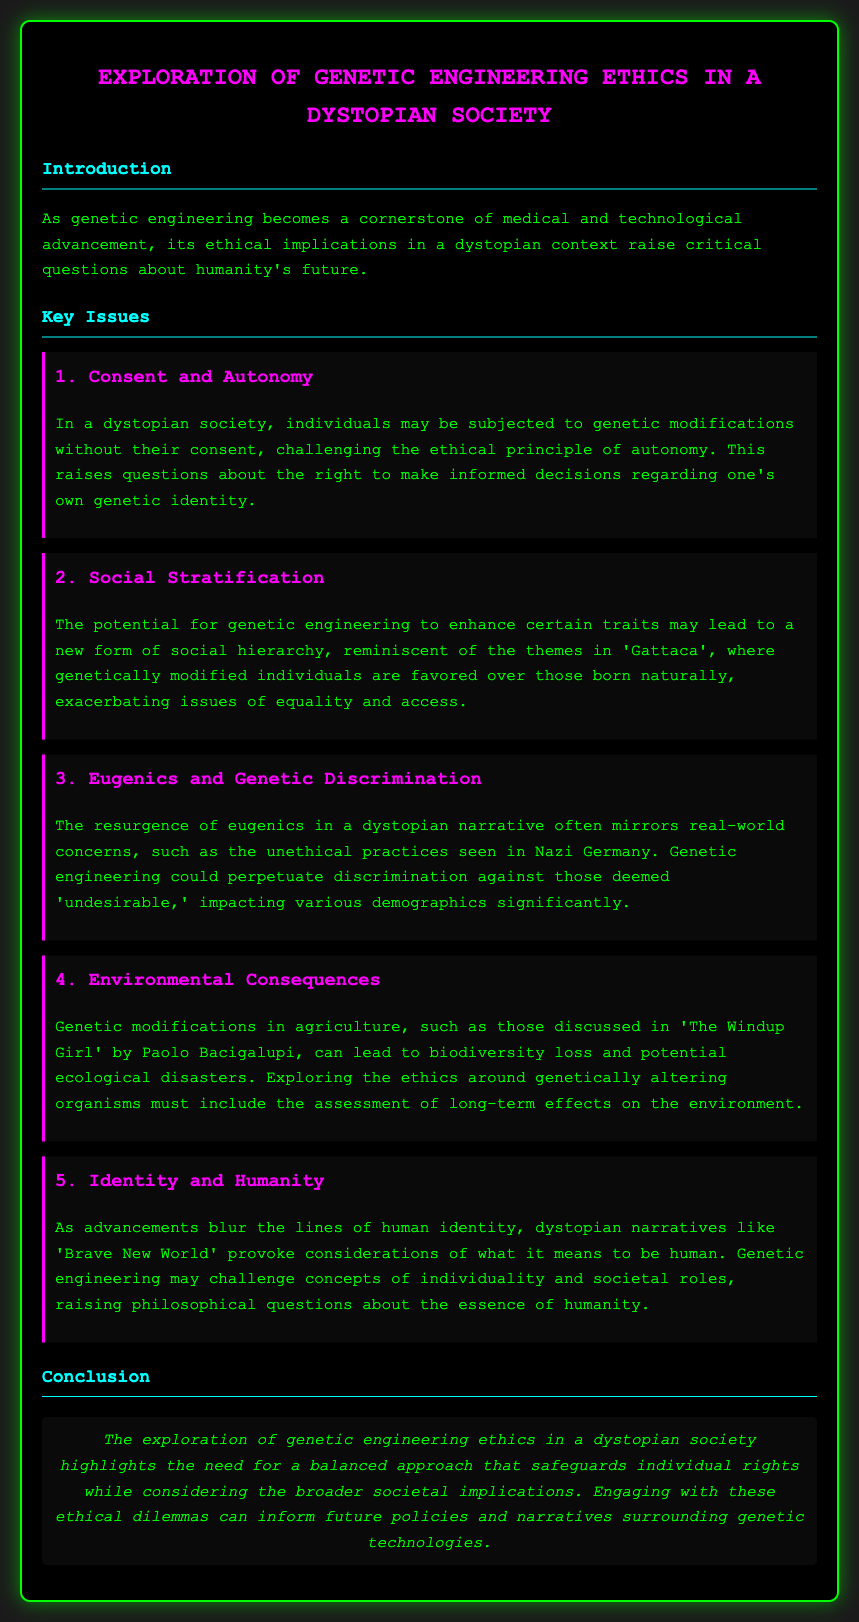What is the main topic of the document? The main topic is the ethical implications of genetic engineering in a dystopian society.
Answer: genetic engineering ethics in a dystopian society What does the first key issue address? The first key issue addresses the challenges related to individual rights in genetic modifications.
Answer: Consent and Autonomy Which dystopian narrative is mentioned in connection with social hierarchy? The narrative mentioned in connection with social hierarchy is 'Gattaca'.
Answer: Gattaca What unethical practices are referenced in the context of eugenics? The reference is made to the unethical practices seen in Nazi Germany.
Answer: Nazi Germany What does the key issue about environmental consequences emphasize? It emphasizes the potential ecological disasters due to genetic modifications in agriculture.
Answer: biodiversity loss and potential ecological disasters How many key issues are outlined in the document? There are five key issues outlined in the document.
Answer: five What philosophical question does genetic engineering raise according to the document? It raises questions about the essence of humanity and individuality.
Answer: essence of humanity What is the need highlighted in the conclusion of the document? The conclusion highlights the need for a balanced approach to genetic engineering ethics.
Answer: balanced approach 